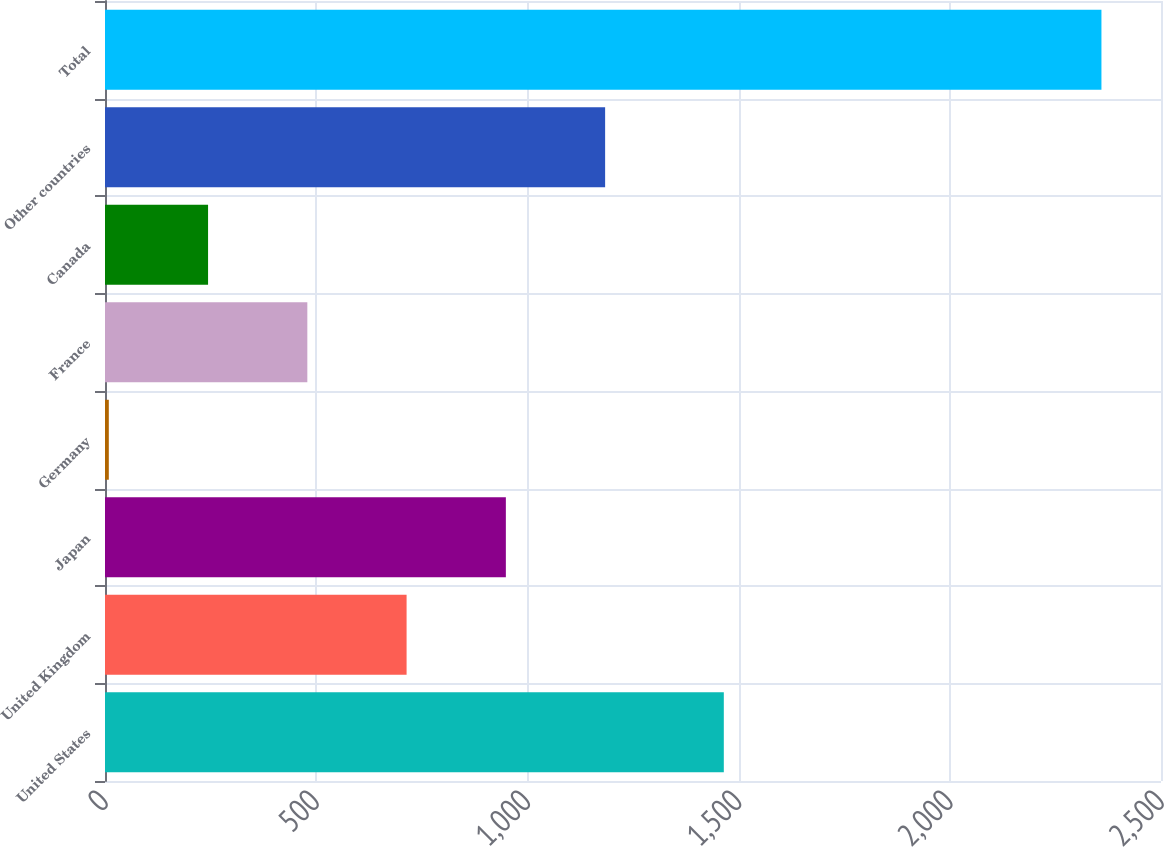Convert chart to OTSL. <chart><loc_0><loc_0><loc_500><loc_500><bar_chart><fcel>United States<fcel>United Kingdom<fcel>Japan<fcel>Germany<fcel>France<fcel>Canada<fcel>Other countries<fcel>Total<nl><fcel>1465<fcel>714<fcel>949<fcel>9<fcel>479<fcel>244<fcel>1184<fcel>2359<nl></chart> 